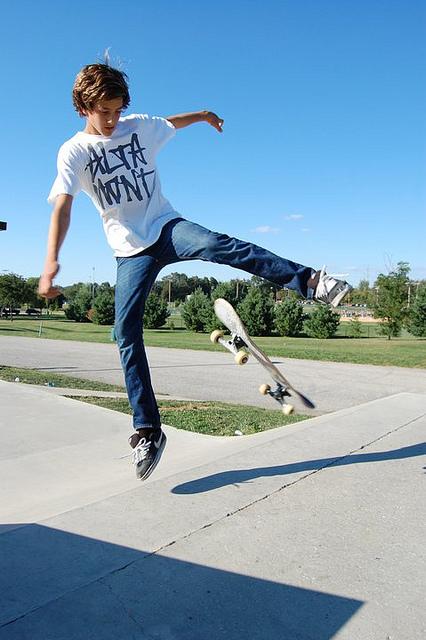Is this going to end safely?
Keep it brief. No. What colors are on the bottom of the skateboard?
Give a very brief answer. White. Do you see any dogs in this photo?
Concise answer only. No. Is it a good idea for the kid to keep his leg high and out of the way?
Quick response, please. Yes. 